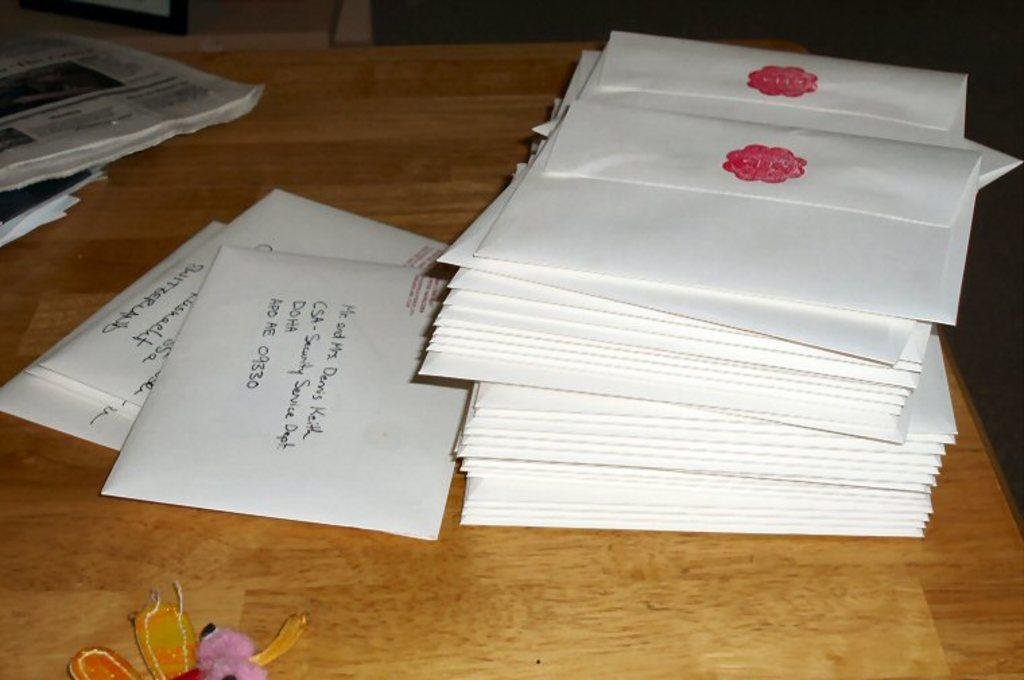<image>
Create a compact narrative representing the image presented. A stack of letters is on a table, one is addressed to a Mr. and Mrs. Demi's Keith CSA- Security Service Dept. DOHA APO AE 09330. 